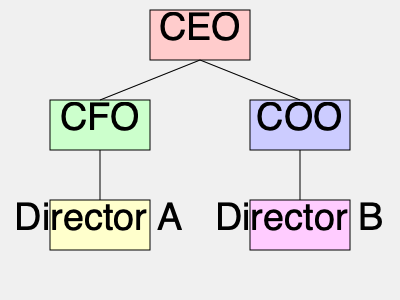In the corporate organizational chart shown, if Director A is accused of misconduct and needs to be removed, how many levels of hierarchy separate the CEO from the position that would need to be filled? To determine the number of levels of hierarchy between the CEO and Director A's position, we need to follow these steps:

1. Identify the CEO's position: The CEO is at the top of the organizational chart.

2. Identify Director A's position: Director A is at the bottom left of the chart.

3. Count the levels between them:
   - Level 1: CEO
   - Level 2: CFO (Director A reports to the CFO)
   - Level 3: Director A

4. Calculate the separation:
   The number of levels separating the CEO from Director A's position is the total number of levels minus 1.

   $3 - 1 = 2$

Therefore, there are 2 levels of hierarchy separating the CEO from the position that would need to be filled if Director A were removed.
Answer: 2 levels 